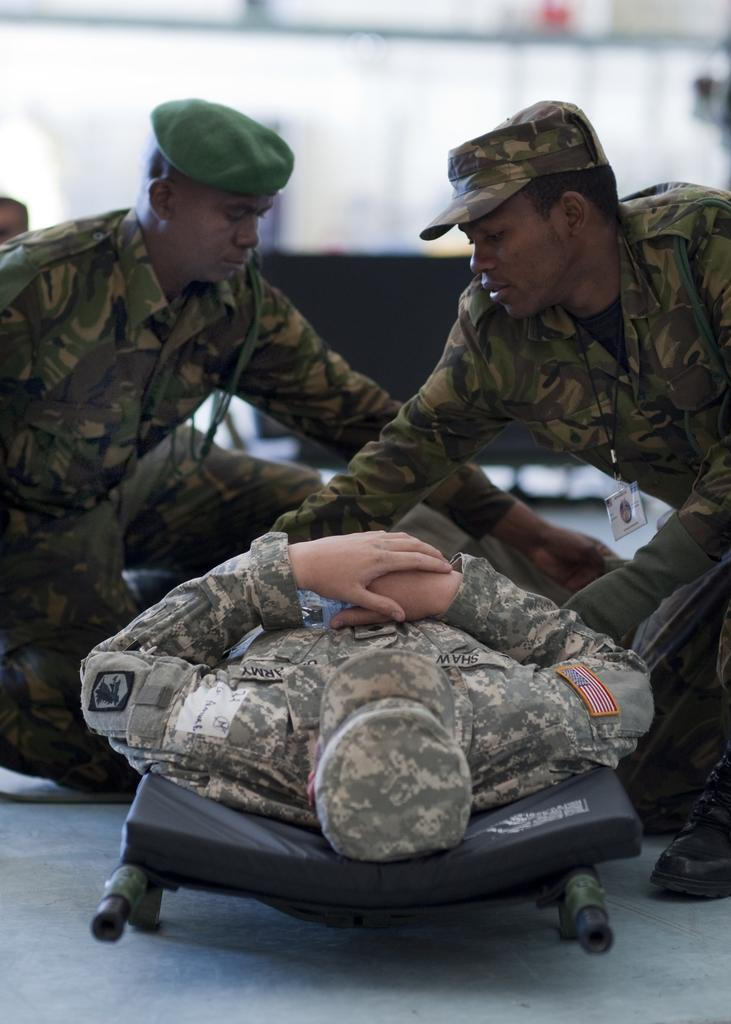What is the main subject of the image? There is a person laying on a stretcher in the image. How many other people are in the image? There are two men in the image. Can you describe the background of the image? The background of the image is blurry. What are the three persons in the image wearing? The three persons in the image are wearing caps. What shape is the frame of the stretcher in the image? There is no frame visible in the image, as the stretcher is not shown in its entirety. 